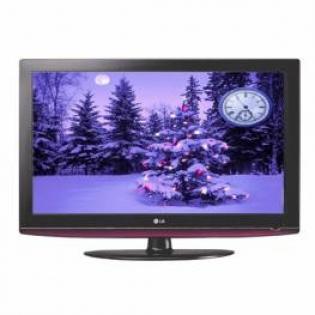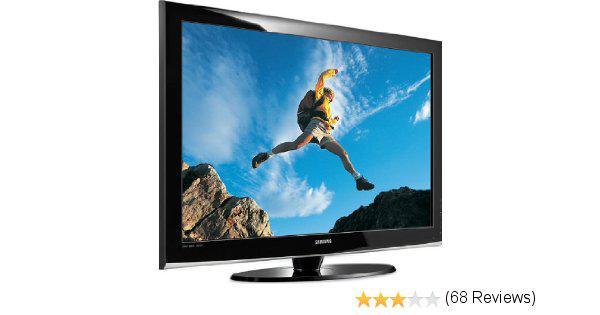The first image is the image on the left, the second image is the image on the right. Examine the images to the left and right. Is the description "One screen is flat and viewed head-on, and the other screen is curved and displayed at an angle." accurate? Answer yes or no. No. The first image is the image on the left, the second image is the image on the right. Examine the images to the left and right. Is the description "The left and right image contains the same number television with at least one curved television." accurate? Answer yes or no. No. 